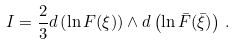Convert formula to latex. <formula><loc_0><loc_0><loc_500><loc_500>I = \frac { 2 } { 3 } d \left ( \ln { F ( \xi ) } \right ) \wedge d \left ( \ln { \bar { F } ( \bar { \xi } ) } \right ) \, .</formula> 